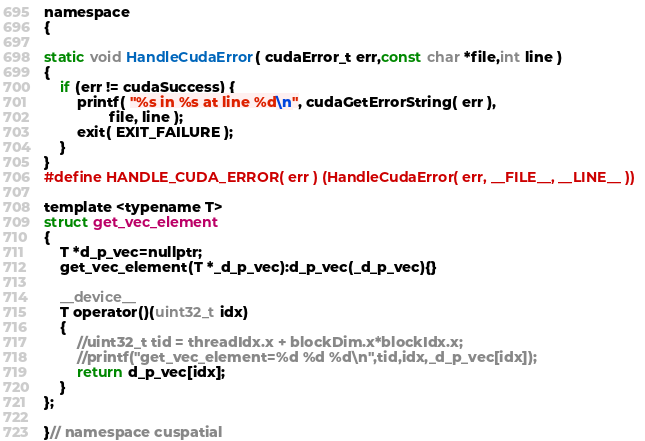Convert code to text. <code><loc_0><loc_0><loc_500><loc_500><_Cuda_>namespace
{

static void HandleCudaError( cudaError_t err,const char *file,int line )
{
    if (err != cudaSuccess) {
        printf( "%s in %s at line %d\n", cudaGetErrorString( err ),
                file, line );
        exit( EXIT_FAILURE );
    }
}
#define HANDLE_CUDA_ERROR( err ) (HandleCudaError( err, __FILE__, __LINE__ ))

template <typename T>
struct get_vec_element
{
    T *d_p_vec=nullptr;
    get_vec_element(T *_d_p_vec):d_p_vec(_d_p_vec){}

    __device__ 
    T operator()(uint32_t idx)
    {
        //uint32_t tid = threadIdx.x + blockDim.x*blockIdx.x;
        //printf("get_vec_element=%d %d %d\n",tid,idx,_d_p_vec[idx]);
        return d_p_vec[idx];
    }
};

}// namespace cuspatial</code> 